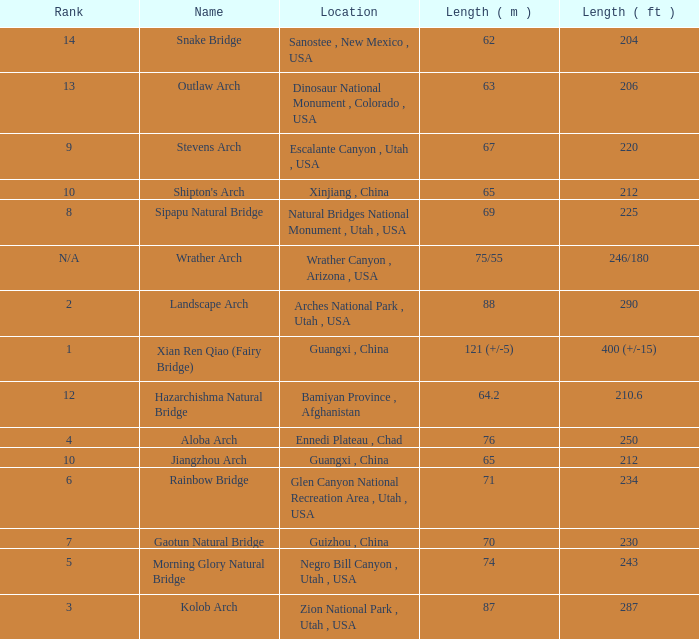What is the length in feet when the length in meters is 64.2? 210.6. 